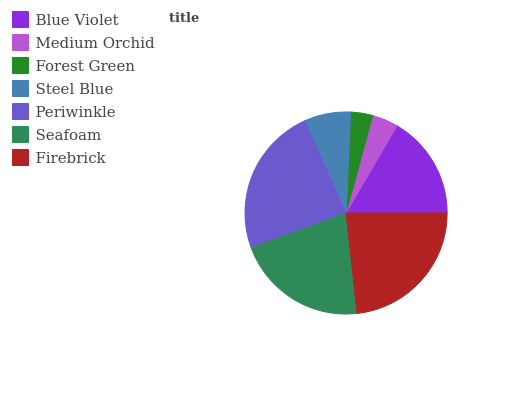Is Forest Green the minimum?
Answer yes or no. Yes. Is Periwinkle the maximum?
Answer yes or no. Yes. Is Medium Orchid the minimum?
Answer yes or no. No. Is Medium Orchid the maximum?
Answer yes or no. No. Is Blue Violet greater than Medium Orchid?
Answer yes or no. Yes. Is Medium Orchid less than Blue Violet?
Answer yes or no. Yes. Is Medium Orchid greater than Blue Violet?
Answer yes or no. No. Is Blue Violet less than Medium Orchid?
Answer yes or no. No. Is Blue Violet the high median?
Answer yes or no. Yes. Is Blue Violet the low median?
Answer yes or no. Yes. Is Steel Blue the high median?
Answer yes or no. No. Is Forest Green the low median?
Answer yes or no. No. 